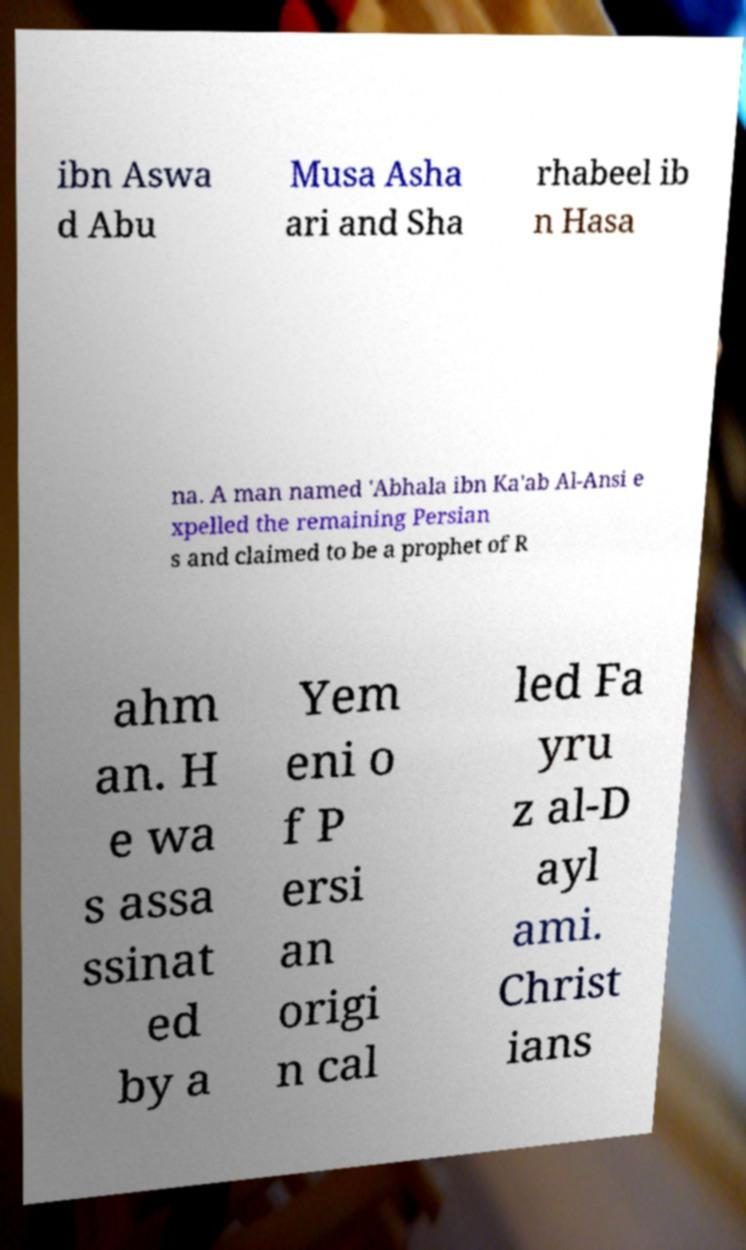I need the written content from this picture converted into text. Can you do that? ibn Aswa d Abu Musa Asha ari and Sha rhabeel ib n Hasa na. A man named 'Abhala ibn Ka'ab Al-Ansi e xpelled the remaining Persian s and claimed to be a prophet of R ahm an. H e wa s assa ssinat ed by a Yem eni o f P ersi an origi n cal led Fa yru z al-D ayl ami. Christ ians 